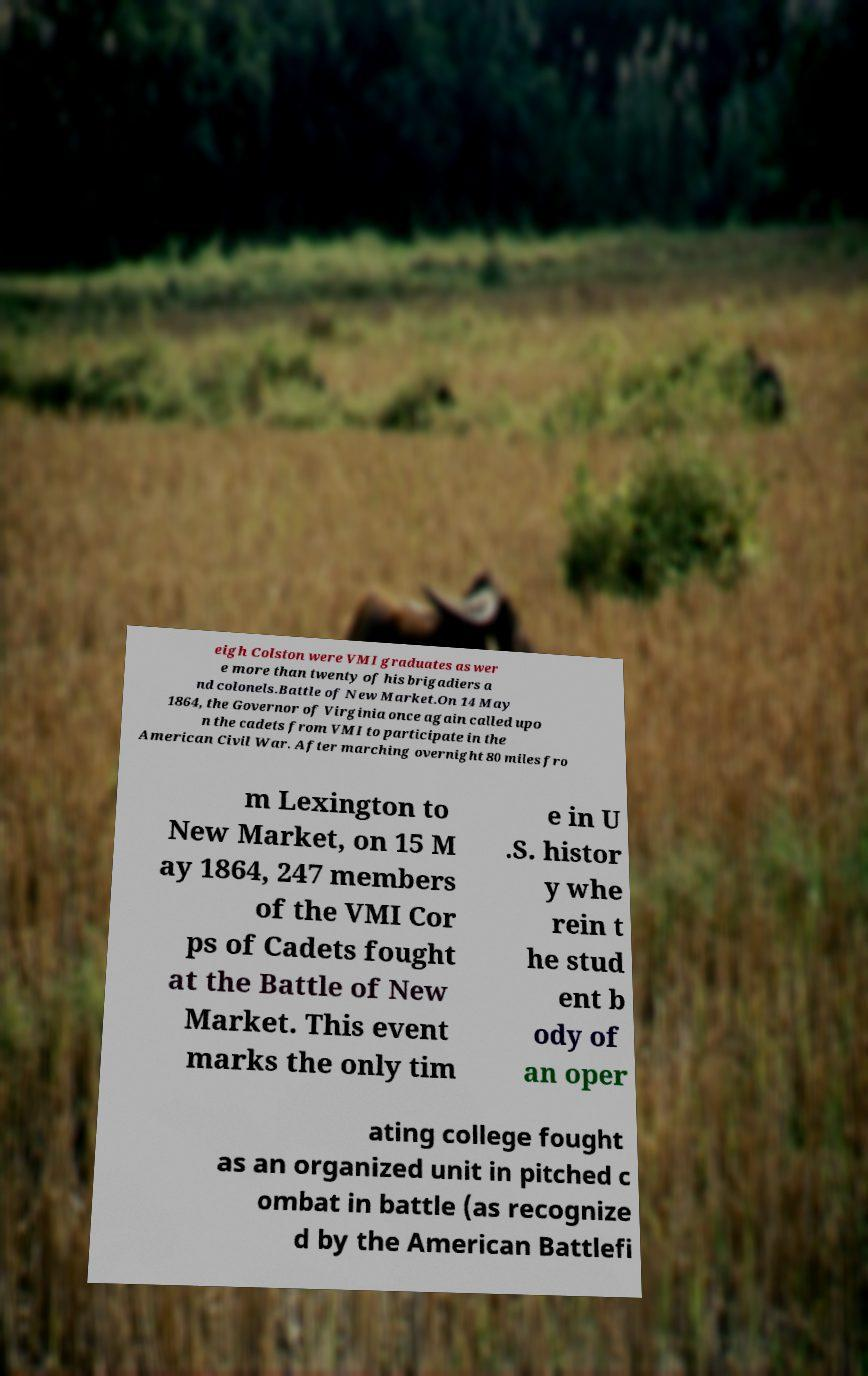What messages or text are displayed in this image? I need them in a readable, typed format. eigh Colston were VMI graduates as wer e more than twenty of his brigadiers a nd colonels.Battle of New Market.On 14 May 1864, the Governor of Virginia once again called upo n the cadets from VMI to participate in the American Civil War. After marching overnight 80 miles fro m Lexington to New Market, on 15 M ay 1864, 247 members of the VMI Cor ps of Cadets fought at the Battle of New Market. This event marks the only tim e in U .S. histor y whe rein t he stud ent b ody of an oper ating college fought as an organized unit in pitched c ombat in battle (as recognize d by the American Battlefi 